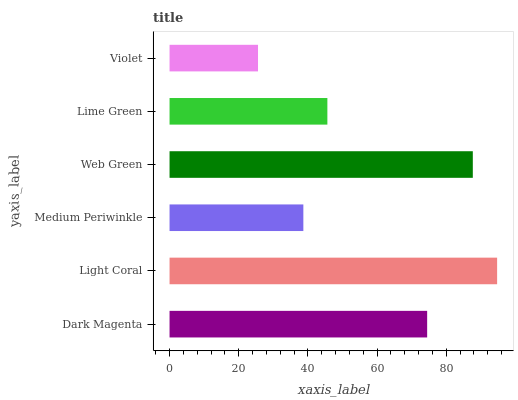Is Violet the minimum?
Answer yes or no. Yes. Is Light Coral the maximum?
Answer yes or no. Yes. Is Medium Periwinkle the minimum?
Answer yes or no. No. Is Medium Periwinkle the maximum?
Answer yes or no. No. Is Light Coral greater than Medium Periwinkle?
Answer yes or no. Yes. Is Medium Periwinkle less than Light Coral?
Answer yes or no. Yes. Is Medium Periwinkle greater than Light Coral?
Answer yes or no. No. Is Light Coral less than Medium Periwinkle?
Answer yes or no. No. Is Dark Magenta the high median?
Answer yes or no. Yes. Is Lime Green the low median?
Answer yes or no. Yes. Is Violet the high median?
Answer yes or no. No. Is Web Green the low median?
Answer yes or no. No. 